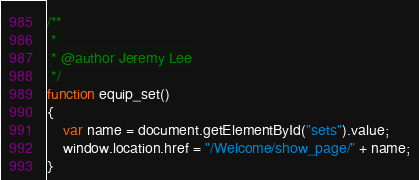Convert code to text. <code><loc_0><loc_0><loc_500><loc_500><_JavaScript_>/**
 * 
 * @author Jeremy Lee
 */
function equip_set()
{
    var name = document.getElementById("sets").value;
    window.location.href = "/Welcome/show_page/" + name;
}</code> 